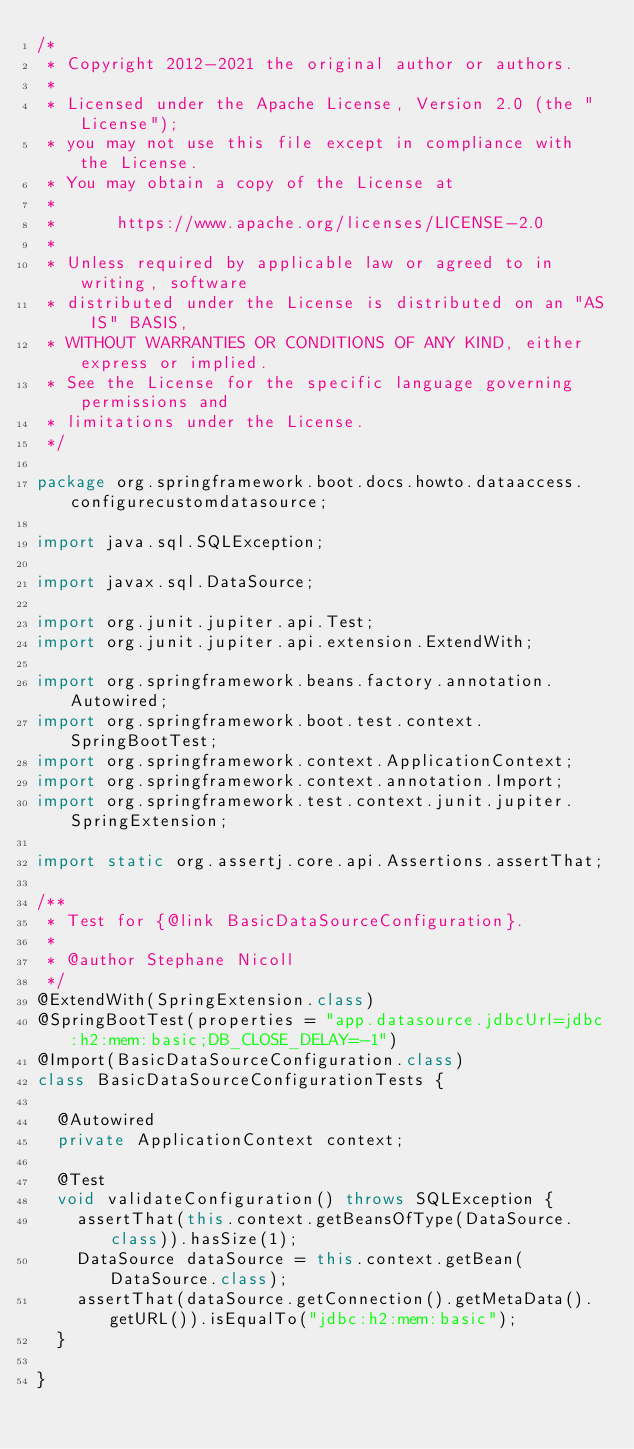Convert code to text. <code><loc_0><loc_0><loc_500><loc_500><_Java_>/*
 * Copyright 2012-2021 the original author or authors.
 *
 * Licensed under the Apache License, Version 2.0 (the "License");
 * you may not use this file except in compliance with the License.
 * You may obtain a copy of the License at
 *
 *      https://www.apache.org/licenses/LICENSE-2.0
 *
 * Unless required by applicable law or agreed to in writing, software
 * distributed under the License is distributed on an "AS IS" BASIS,
 * WITHOUT WARRANTIES OR CONDITIONS OF ANY KIND, either express or implied.
 * See the License for the specific language governing permissions and
 * limitations under the License.
 */

package org.springframework.boot.docs.howto.dataaccess.configurecustomdatasource;

import java.sql.SQLException;

import javax.sql.DataSource;

import org.junit.jupiter.api.Test;
import org.junit.jupiter.api.extension.ExtendWith;

import org.springframework.beans.factory.annotation.Autowired;
import org.springframework.boot.test.context.SpringBootTest;
import org.springframework.context.ApplicationContext;
import org.springframework.context.annotation.Import;
import org.springframework.test.context.junit.jupiter.SpringExtension;

import static org.assertj.core.api.Assertions.assertThat;

/**
 * Test for {@link BasicDataSourceConfiguration}.
 *
 * @author Stephane Nicoll
 */
@ExtendWith(SpringExtension.class)
@SpringBootTest(properties = "app.datasource.jdbcUrl=jdbc:h2:mem:basic;DB_CLOSE_DELAY=-1")
@Import(BasicDataSourceConfiguration.class)
class BasicDataSourceConfigurationTests {

	@Autowired
	private ApplicationContext context;

	@Test
	void validateConfiguration() throws SQLException {
		assertThat(this.context.getBeansOfType(DataSource.class)).hasSize(1);
		DataSource dataSource = this.context.getBean(DataSource.class);
		assertThat(dataSource.getConnection().getMetaData().getURL()).isEqualTo("jdbc:h2:mem:basic");
	}

}
</code> 